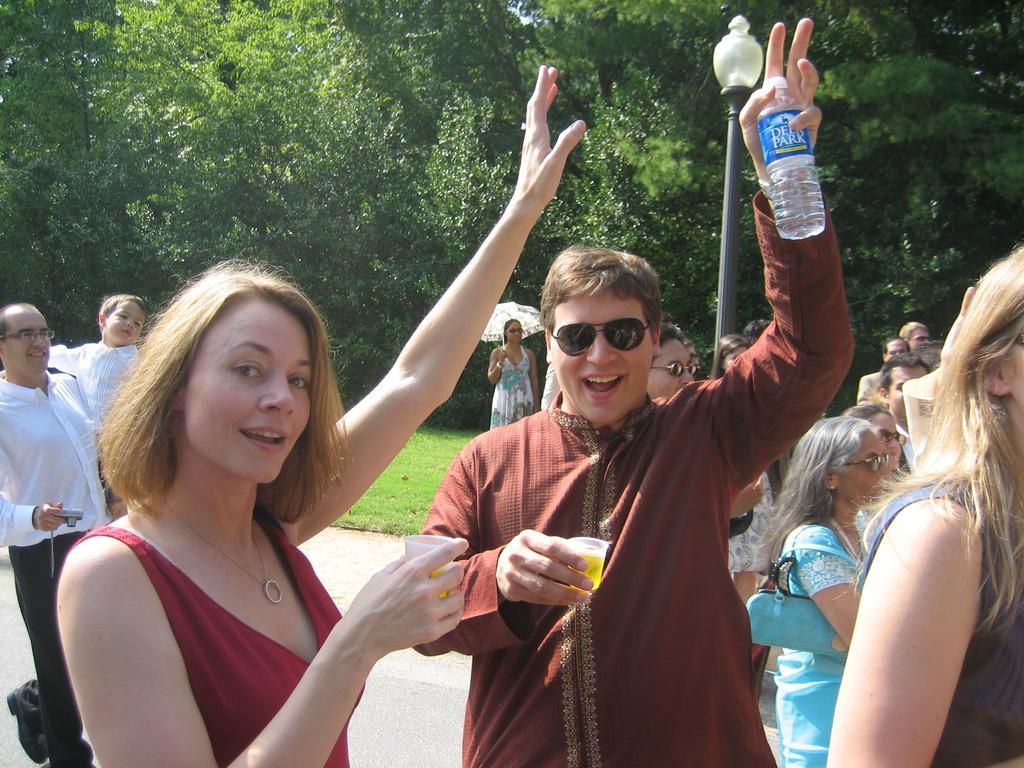Describe this image in one or two sentences. In the picture we can see some people are standing on the path, one man is holding a water bottle on other hand there is a glass and a woman is holding a glass and raising one hand up, in background we can see a woman holding a umbrella, and there is a street light with trees. 